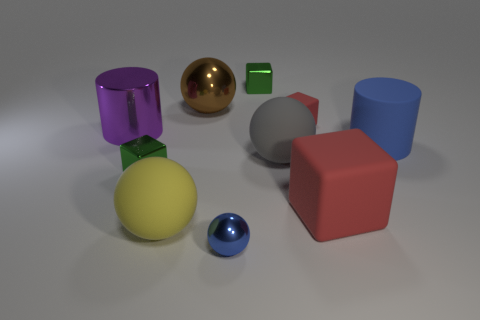How many other objects are the same color as the tiny matte block?
Provide a short and direct response. 1. There is a blue object that is the same size as the brown metallic thing; what shape is it?
Your response must be concise. Cylinder. There is a blue thing in front of the matte object to the left of the small ball; what number of small blue metallic balls are on the right side of it?
Make the answer very short. 0. What number of metallic objects are either large red cubes or red objects?
Your answer should be compact. 0. What is the color of the object that is behind the large blue matte cylinder and left of the big yellow thing?
Ensure brevity in your answer.  Purple. There is a green object that is in front of the metallic cylinder; does it have the same size as the big gray ball?
Give a very brief answer. No. How many things are cylinders that are to the right of the big red matte cube or brown things?
Give a very brief answer. 2. Is there a purple shiny cube of the same size as the gray ball?
Provide a short and direct response. No. There is a purple object that is the same size as the rubber cylinder; what is its material?
Give a very brief answer. Metal. There is a big thing that is in front of the big blue rubber cylinder and on the left side of the tiny blue ball; what shape is it?
Your answer should be compact. Sphere. 